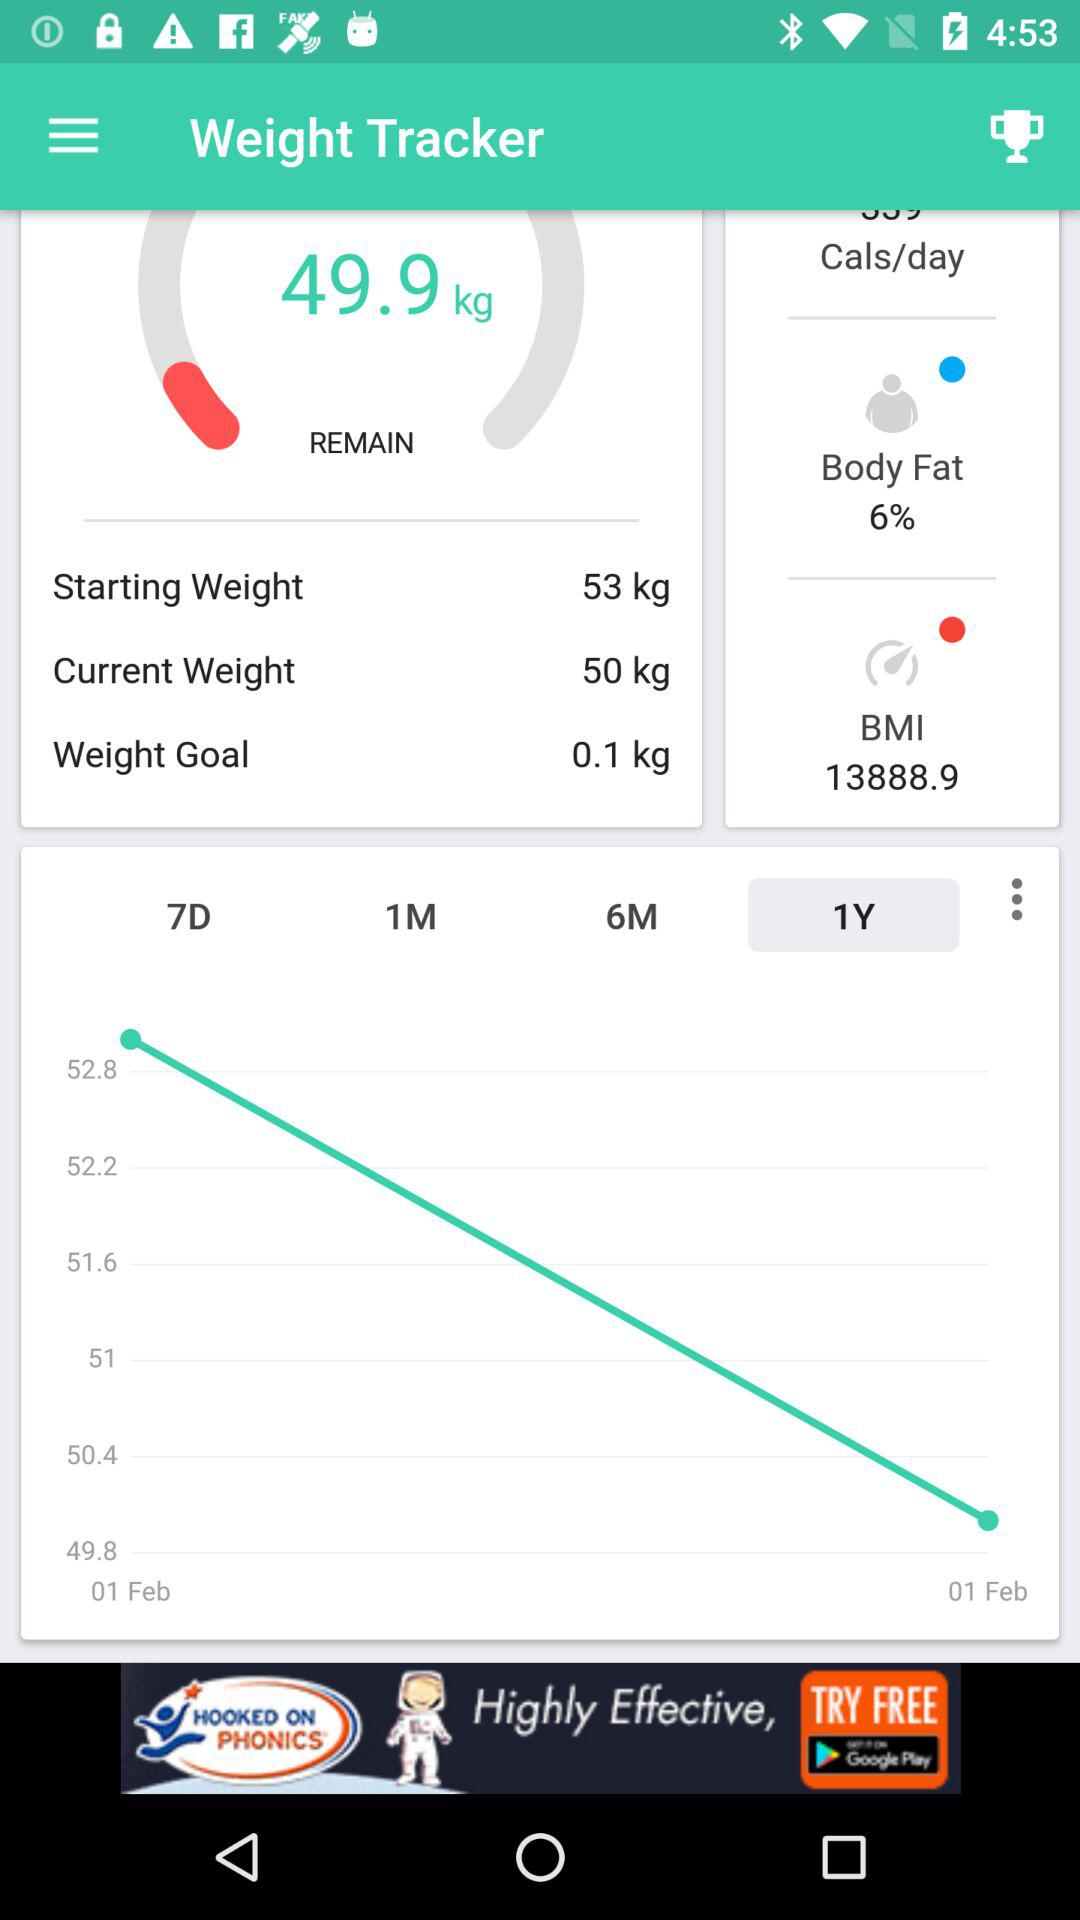How much more weight do I need to lose to reach my goal?
Answer the question using a single word or phrase. 0.1 kg 